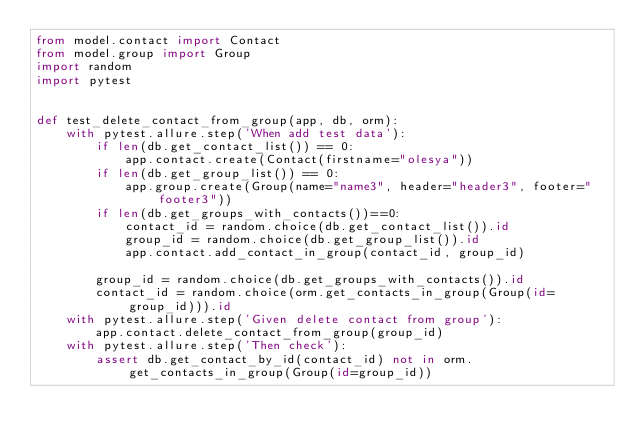Convert code to text. <code><loc_0><loc_0><loc_500><loc_500><_Python_>from model.contact import Contact
from model.group import Group
import random
import pytest


def test_delete_contact_from_group(app, db, orm):
    with pytest.allure.step('When add test data'):
        if len(db.get_contact_list()) == 0:
            app.contact.create(Contact(firstname="olesya"))
        if len(db.get_group_list()) == 0:
            app.group.create(Group(name="name3", header="header3", footer="footer3"))
        if len(db.get_groups_with_contacts())==0:
            contact_id = random.choice(db.get_contact_list()).id
            group_id = random.choice(db.get_group_list()).id
            app.contact.add_contact_in_group(contact_id, group_id)

        group_id = random.choice(db.get_groups_with_contacts()).id
        contact_id = random.choice(orm.get_contacts_in_group(Group(id=group_id))).id
    with pytest.allure.step('Given delete contact from group'):
        app.contact.delete_contact_from_group(group_id)
    with pytest.allure.step('Then check'):
        assert db.get_contact_by_id(contact_id) not in orm.get_contacts_in_group(Group(id=group_id))</code> 